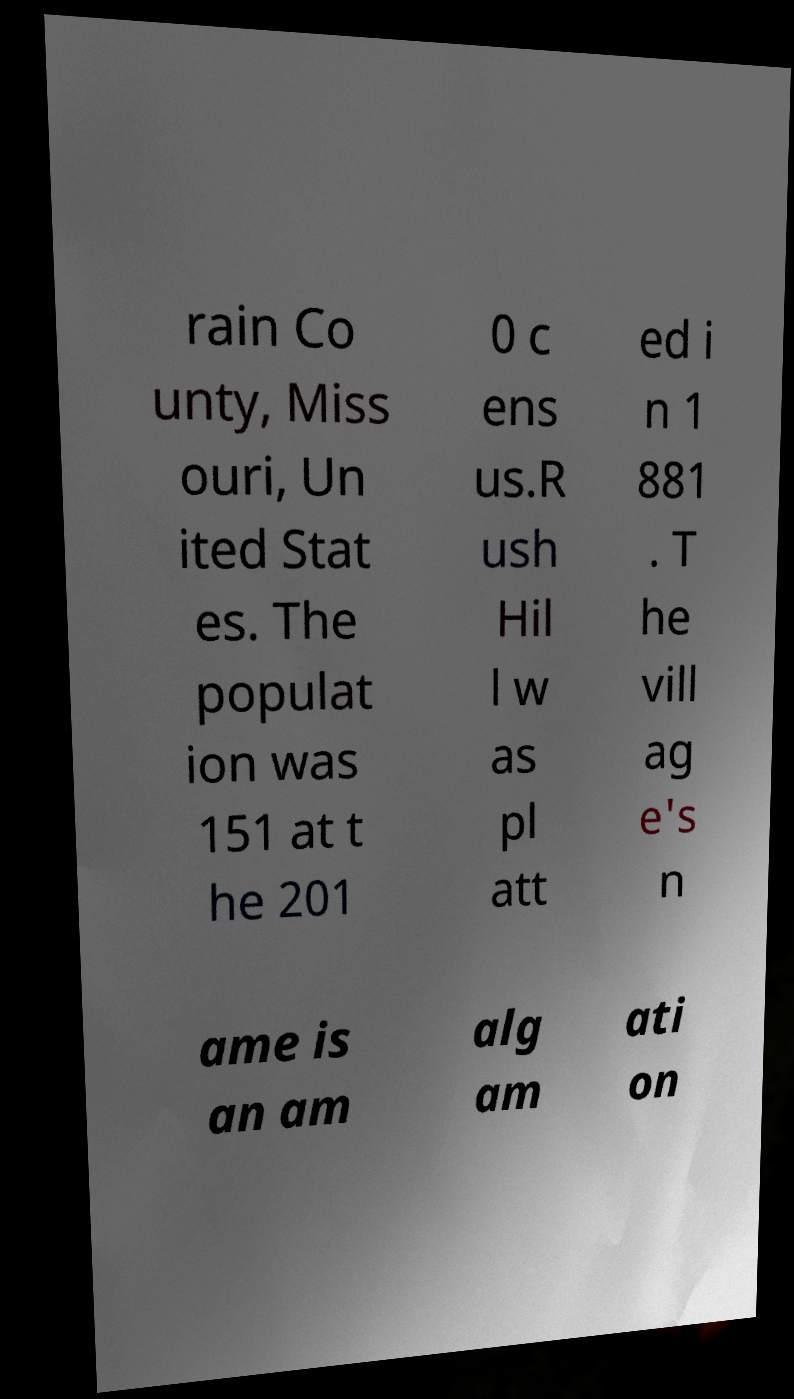For documentation purposes, I need the text within this image transcribed. Could you provide that? rain Co unty, Miss ouri, Un ited Stat es. The populat ion was 151 at t he 201 0 c ens us.R ush Hil l w as pl att ed i n 1 881 . T he vill ag e's n ame is an am alg am ati on 